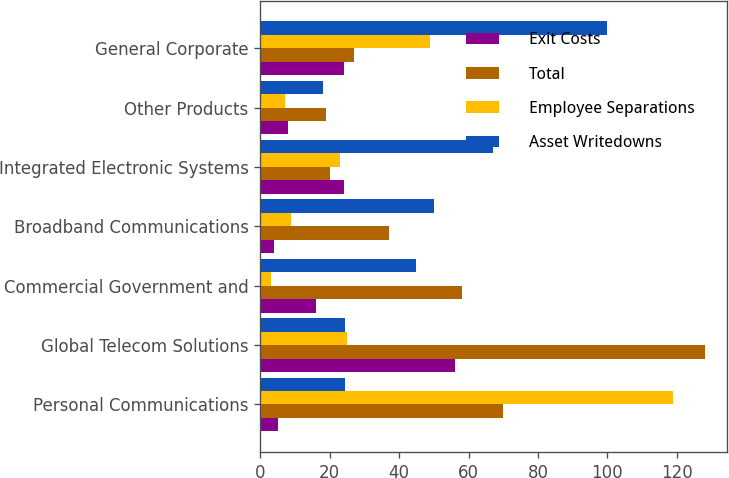Convert chart. <chart><loc_0><loc_0><loc_500><loc_500><stacked_bar_chart><ecel><fcel>Personal Communications<fcel>Global Telecom Solutions<fcel>Commercial Government and<fcel>Broadband Communications<fcel>Integrated Electronic Systems<fcel>Other Products<fcel>General Corporate<nl><fcel>Exit Costs<fcel>5<fcel>56<fcel>16<fcel>4<fcel>24<fcel>8<fcel>24<nl><fcel>Total<fcel>70<fcel>128<fcel>58<fcel>37<fcel>20<fcel>19<fcel>27<nl><fcel>Employee Separations<fcel>119<fcel>25<fcel>3<fcel>9<fcel>23<fcel>7<fcel>49<nl><fcel>Asset Writedowns<fcel>24.5<fcel>24.5<fcel>45<fcel>50<fcel>67<fcel>18<fcel>100<nl></chart> 